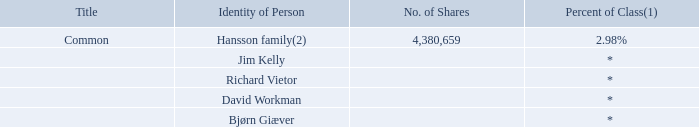ITEM 7. MAJOR SHAREHOLDERS AND RELATED PARTY TRANSACTIONS
A. Major Shareholders
The following table sets forth information regarding beneficial ownership of our common shares for (i) owners of more than five percent of our common shares and (ii) our directors and officers, of which we are aware of the date of this annual report.
(1) Based on 147,230,634 common shares outstanding as of the date of this annual report.
(2) The holdings of High Seas AS, which are for the economic interest of members of the Hansson family, as well as the personal holdings of our Chief Executive Officer and Chairman, Mr. Herbjorn Hansson, and our director, Alexander Hansson, are included in the amount reported herein.
* Less than 1% of our common outstanding shares.
As of April 14, 2020, we had 575 holders of record in the United States, including Cede & Co., which is the Depositary Trust Company’s nominee for holding shares on behalf of brokerage firms, as a single holder of record. We had a total of 147,230,634 Common Shares outstanding as of the date of this annual report.
How many common shares were outstanding as of the date of this annual report? 147,230,634. How many shares are owned by the Hansson family? 4,380,659. What is the percentage of shares owned by the Hanssen family? 2.98%. What is the total number of shares owned by the Hanssen family and Richard Vietor? (4,380,659 + 0) 
Answer: 4380659. What is the average number of shares owned by the Hanssen family and Jim Kelly? (4,380,659 + 0)/2 
Answer: 2190329.5. What is the total number of shares owned by David Workman and Bjørn Giæver? 0 + 0 
Answer: 0. 